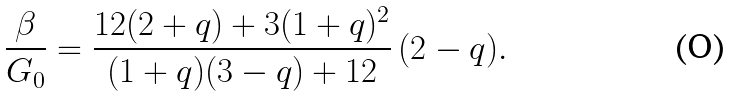Convert formula to latex. <formula><loc_0><loc_0><loc_500><loc_500>\frac { \beta } { G _ { 0 } } = \frac { 1 2 ( 2 + q ) + 3 ( 1 + q ) ^ { 2 } } { ( 1 + q ) ( 3 - q ) + 1 2 } \, ( 2 - q ) .</formula> 